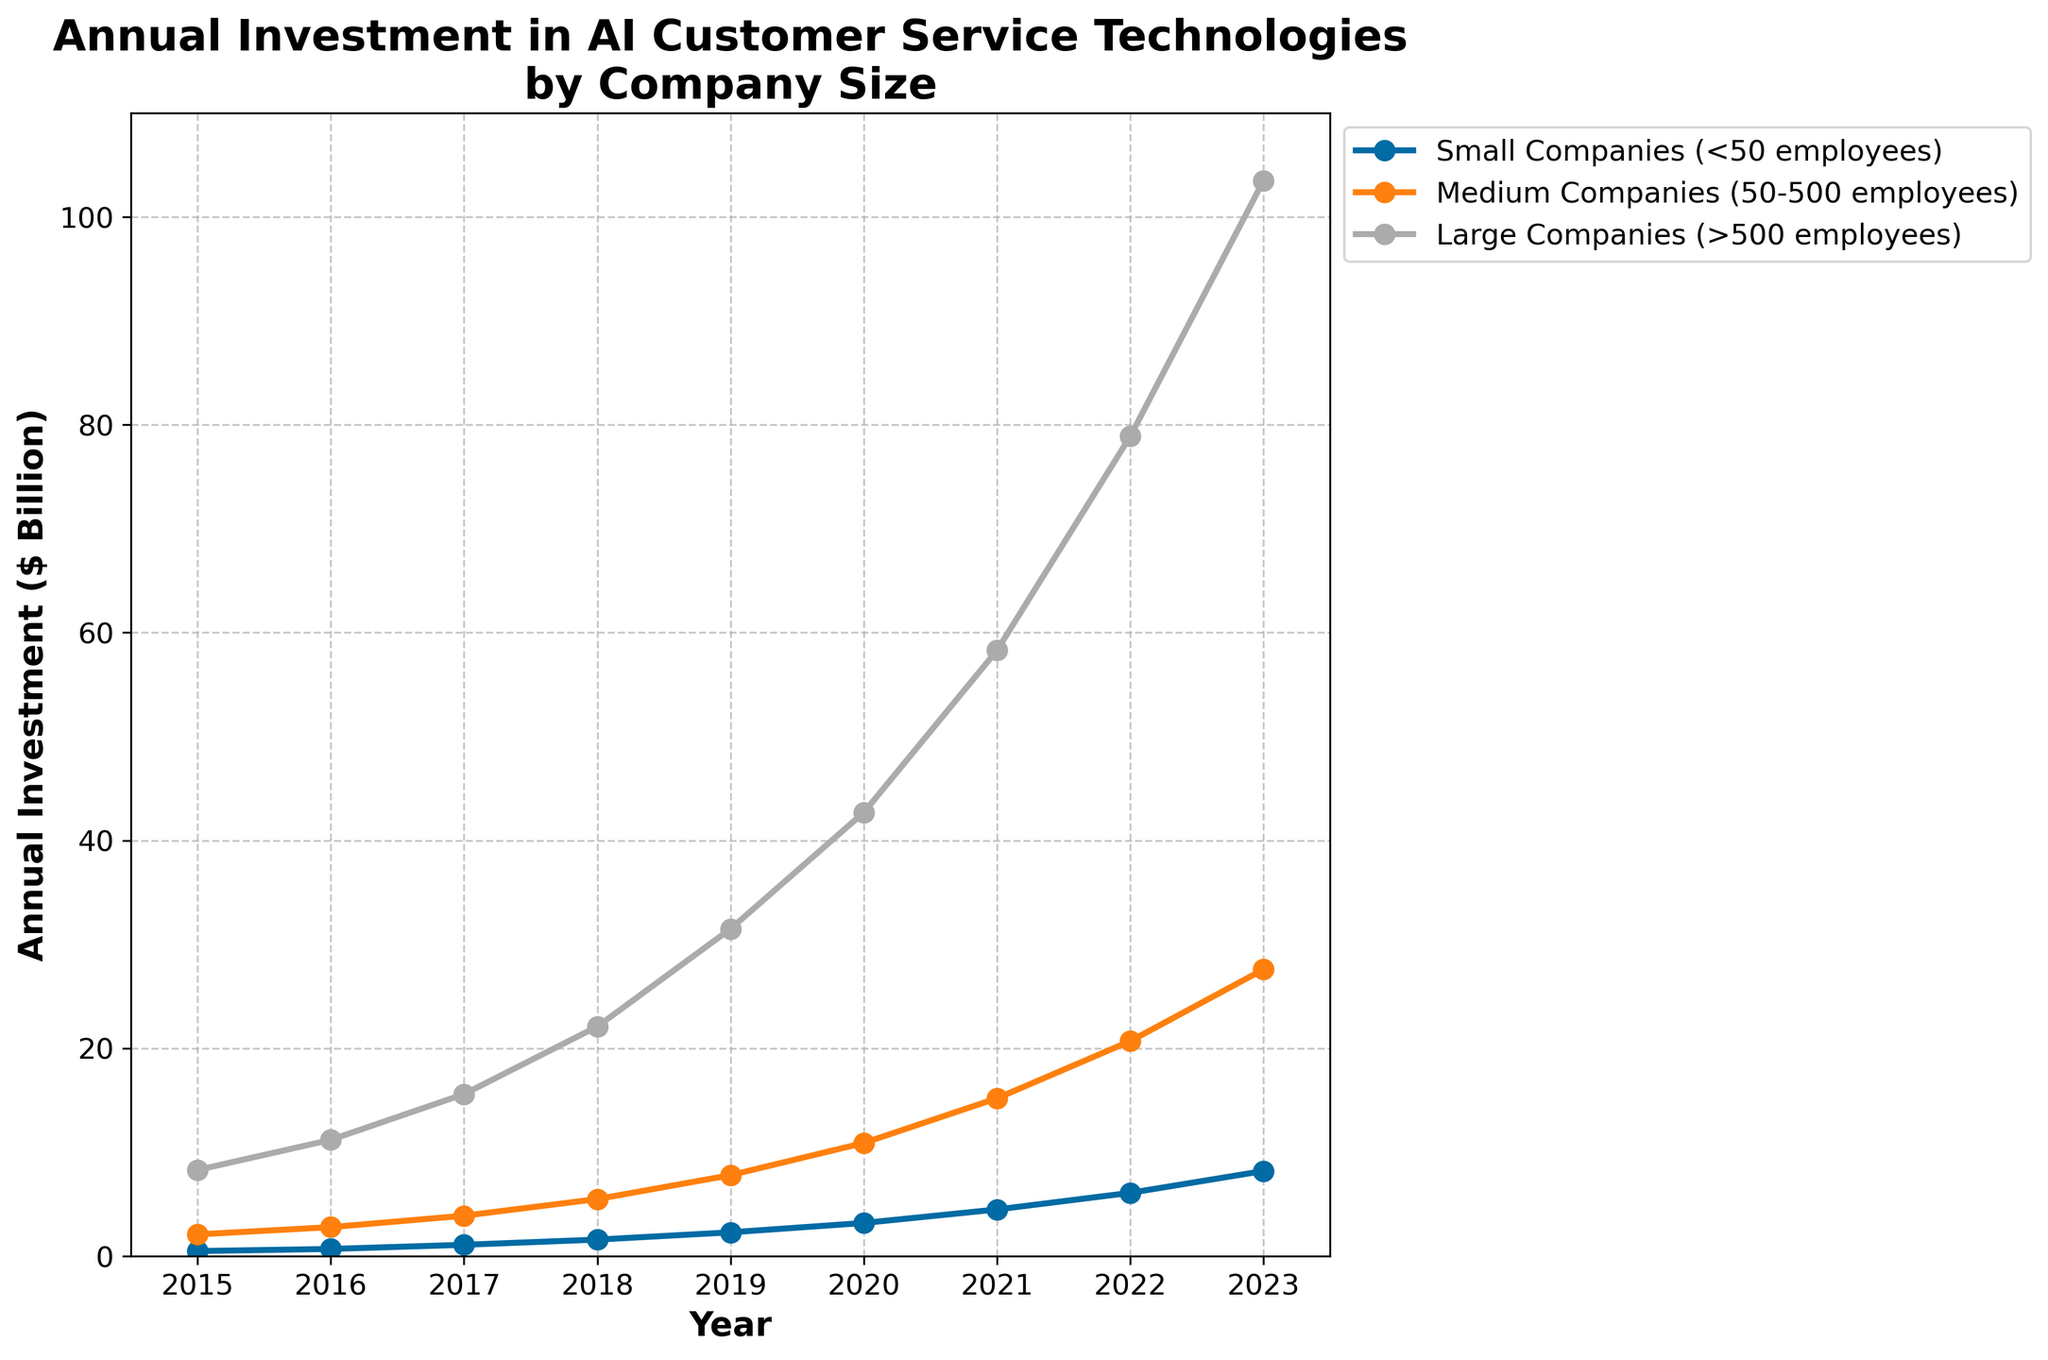What is the trend of annual investment in AI customer service technologies for small companies (<50 employees) from 2015 to 2023? From the figure, the line representing small companies shows a steady increase from 0.5 to 8.2 billion dollars between 2015 and 2023.
Answer: Steady upward trend Which company size had the highest annual investment in AI customer service technologies in 2023? The line for large companies (>500 employees) is the highest on the y-axis in 2023.
Answer: Large companies By how much did the annual investment in AI customer service technologies increase for medium companies (50-500 employees) from 2015 to 2023? In the figure, the value for medium companies in 2015 is 2.1 billion, and in 2023 it is 27.6 billion. The difference is 27.6 - 2.1 = 25.5 billion dollars.
Answer: 25.5 billion dollars Did any company size maintain a consistent pace of increase in annual investment across the years, and if so, which one? Each company's line shows a steady increase but Large companies show a more exponential increase. Small and Medium companies increase steadily but at an accelerating rate from 2020 onwards.
Answer: No What was the proportion of annual investment made by small companies (<50 employees) compared to large companies (>500 employees) in 2020? The figure shows 3.2 billion for small companies and 42.7 billion for large companies in 2020. The ratio is 3.2 / 42.7.
Answer: Approximately 0.0751 or 7.5% In which year did medium companies (50-500 employees) first surpass 10 billion dollars in annual investment? The line representing medium companies crosses the 10 billion mark between 2019 and 2020. In 2020, the value is 10.9 billion.
Answer: 2020 Between which consecutive years did large companies (>500 employees) experience the highest growth in annual investment? By inspecting the figure, the slopes of the lines indicate that the largest increase in the y-value for large companies occurred between 2021 and 2022 with a difference from 58.3 to 78.9 billion.
Answer: Between 2021 and 2022 How does the growth rate of annual investments compare between small companies (<50 employees) and medium companies (50-500 employees) from 2018 to 2020? From 2018 to 2020, small companies increased from 1.6 to 3.2 billion (doubling), while medium companies rose from 5.5 to 10.9 billion, also nearly doubling. Therefore, the growth rates are comparable.
Answer: Similar growth rates Which year saw the sharpest increase for small companies (<50 employees) in annual investment? In the figure, the line for small companies shows the steepest increase between 2022 and 2023 from 6.1 to 8.2 billion.
Answer: Between 2022 and 2023 What were the values of annual investments for each company size in 2018? By referring to the exact y-values in the figure for the year 2018: Small companies = 1.6 billion, Medium companies = 5.5 billion, Large companies = 22.1 billion.
Answer: Small: 1.6 billion, Medium: 5.5 billion, Large: 22.1 billion 